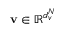Convert formula to latex. <formula><loc_0><loc_0><loc_500><loc_500>v \in \mathbb { R } ^ { d _ { v } ^ { N } }</formula> 